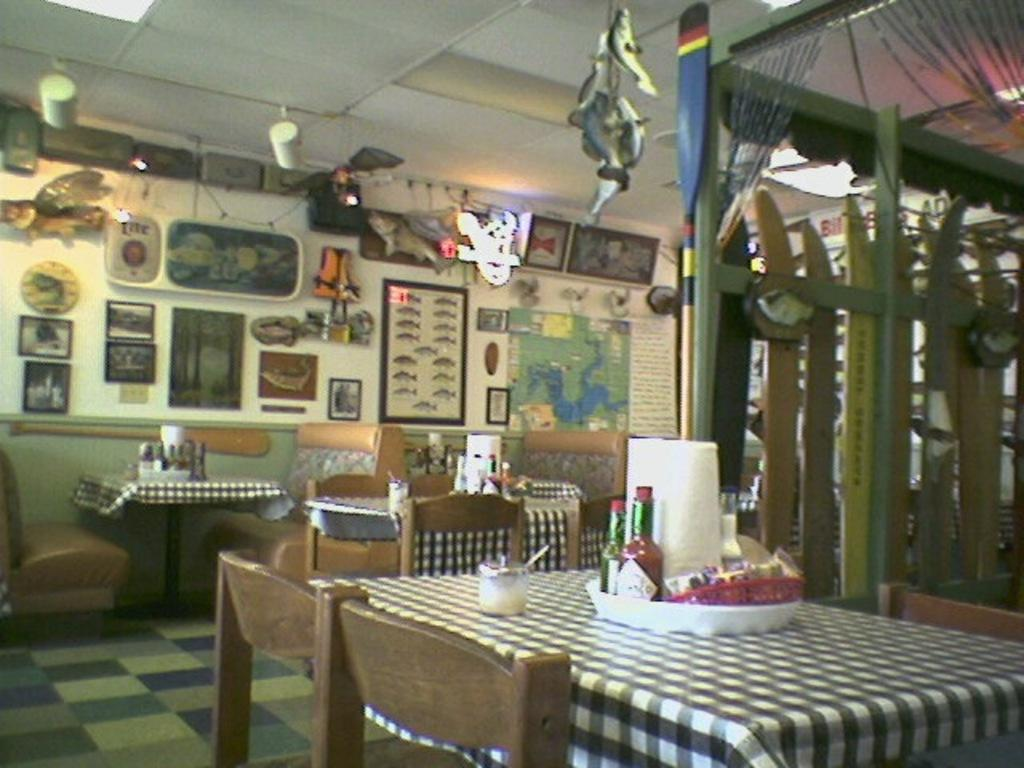What type of furniture is present in the image? There is a dining table in the image. What objects can be seen on the dining table? There are bottles on the dining table. What type of seating is available in the image? There are chairs in the image. What is the income of the stick in the image? There is no stick present in the image, so it is not possible to determine its income. 